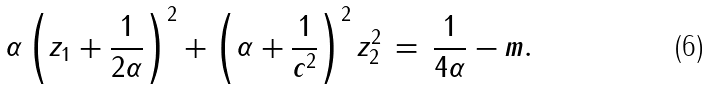Convert formula to latex. <formula><loc_0><loc_0><loc_500><loc_500>\alpha \left ( z _ { 1 } + \frac { 1 } { 2 \alpha } \right ) ^ { 2 } + \left ( \alpha + \frac { 1 } { c ^ { 2 } } \right ) ^ { 2 } z _ { 2 } ^ { 2 } \, = \, \frac { 1 } { 4 \alpha } - m .</formula> 